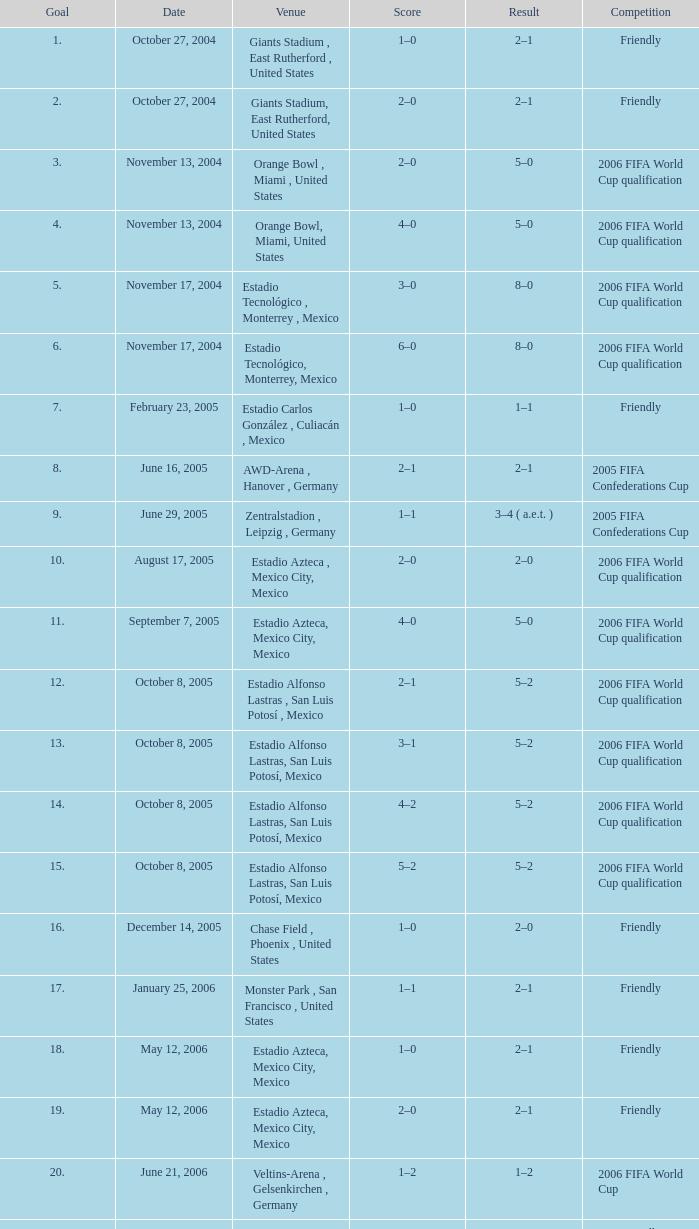What score is associated with the october 8, 2005 match at estadio alfonso lastras, san luis potosí, mexico? 2–1, 3–1, 4–2, 5–2. 